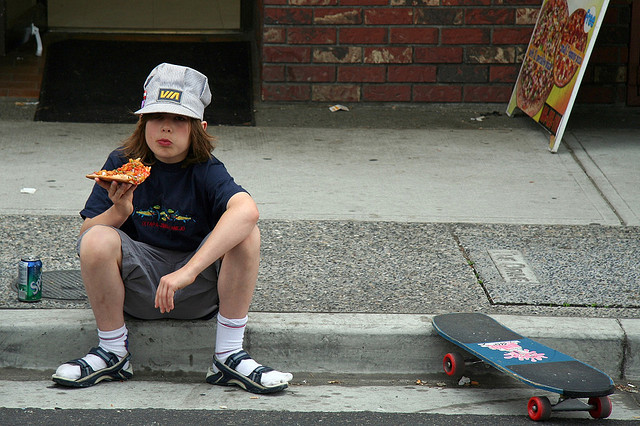Extract all visible text content from this image. VIA Sp 